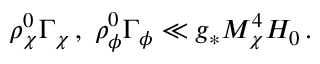<formula> <loc_0><loc_0><loc_500><loc_500>\rho _ { \chi } ^ { 0 } \Gamma _ { \chi } \, , \, \rho _ { \phi } ^ { 0 } \Gamma _ { \phi } \ll g _ { * } M _ { \chi } ^ { 4 } H _ { 0 } \, .</formula> 